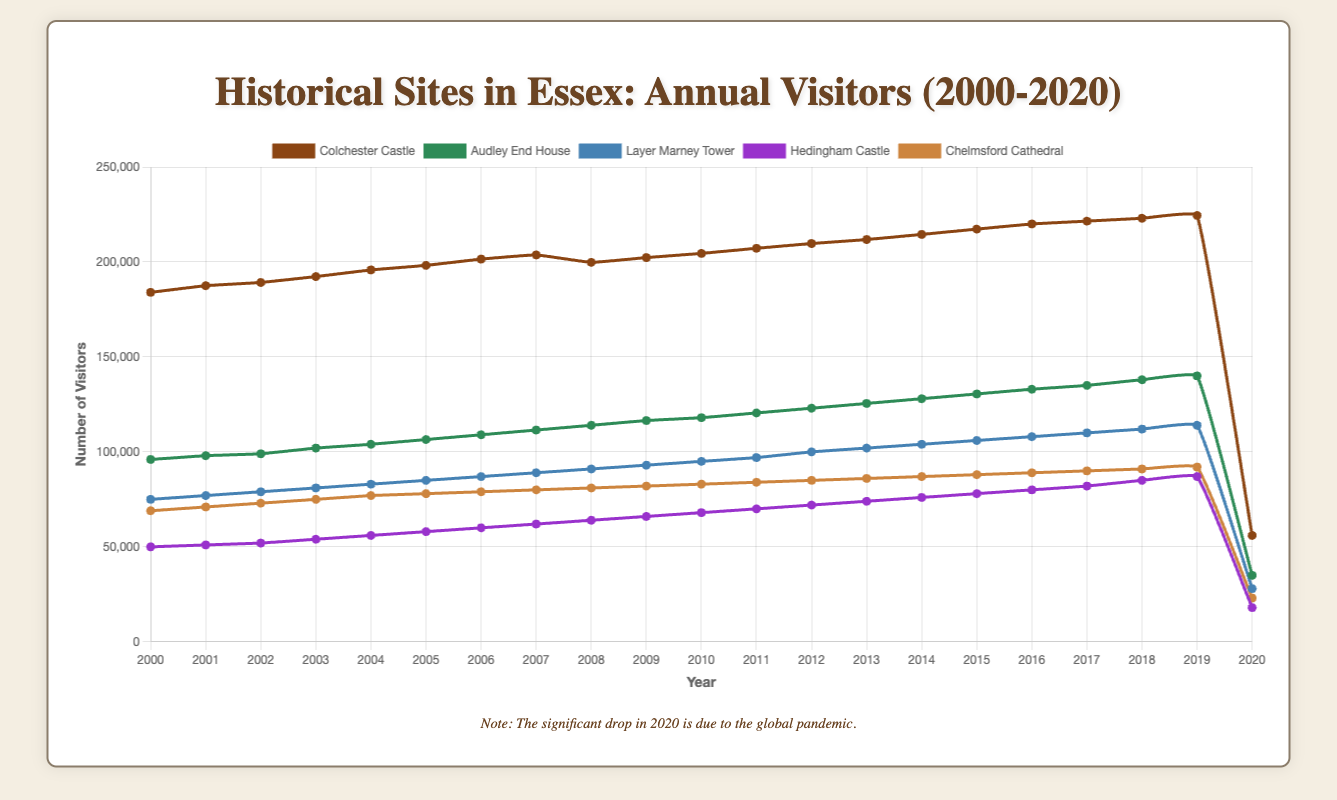- What was the visitor count for Colchester Castle in 2005? To find the visitor count for Colchester Castle in 2005, simply look at the data point for that year.
Answer: 198200 - How much did the number of visitors to Audley End House increase from 2000 to 2020? Subtract the number of visitors in 2000 from the number of visitors in 2020 for Audley End House. (35000 - 96000)
Answer: -61000 - Which historical site had the highest number of visitors in 2010? Look at the data points for all sites in the year 2010 and find the highest value.
Answer: Colchester Castle - Compare the visitor counts between Layer Marney Tower and Hedingham Castle in 2018. Which site had more visitors? Refer to the data points for both sites in 2018. Layer Marney Tower had 112000 visitors, while Hedingham Castle had 85000 visitors. Layer Marney Tower had more.
Answer: Layer Marney Tower - By how much did the visitor count for Chelmsford Cathedral increase from 2003 to 2011? Subtract the number of visitors in 2003 from the number of visitors in 2011 for Chelmsford Cathedral. (84000 - 75000)
Answer: 9000 - What is the maximum number of visitors recorded for Colchester Castle between 2000 and 2020? Look through the data for Colchester Castle from 2000 to 2020 and identify the highest value, disregarding the drop in 2020.
Answer: 224500 - In which year did Hedingham Castle surpass 80000 visitors for the first time? Look at the data points for Hedingham Castle and find the first year where the number of visitors exceeds 80000.
Answer: 2016 - What caused the significant drop in visitors to all sites in 2020? The note under the chart mentions that the significant drop in 2020 is due to the global pandemic.
Answer: Global pandemic - Calculate the average annual visitors for Layer Marney Tower from 2010 to 2019. Sum the visitor counts for Layer Marney Tower from 2010 to 2019, then divide by the number of years within this range (10 years). (95000+97000+100000+102000+104000+106000+108000+110000+112000+114000)/10 = 103200
Answer: 103200 - Between which consecutive years did Audley End House see the largest increase in visitors? Calculate the difference in the number of visitors between each pair of consecutive years for Audley End House, and identify the pair with the largest increase. The highest increase is between 2018 and 2019.
Answer: 2018 to 2019 